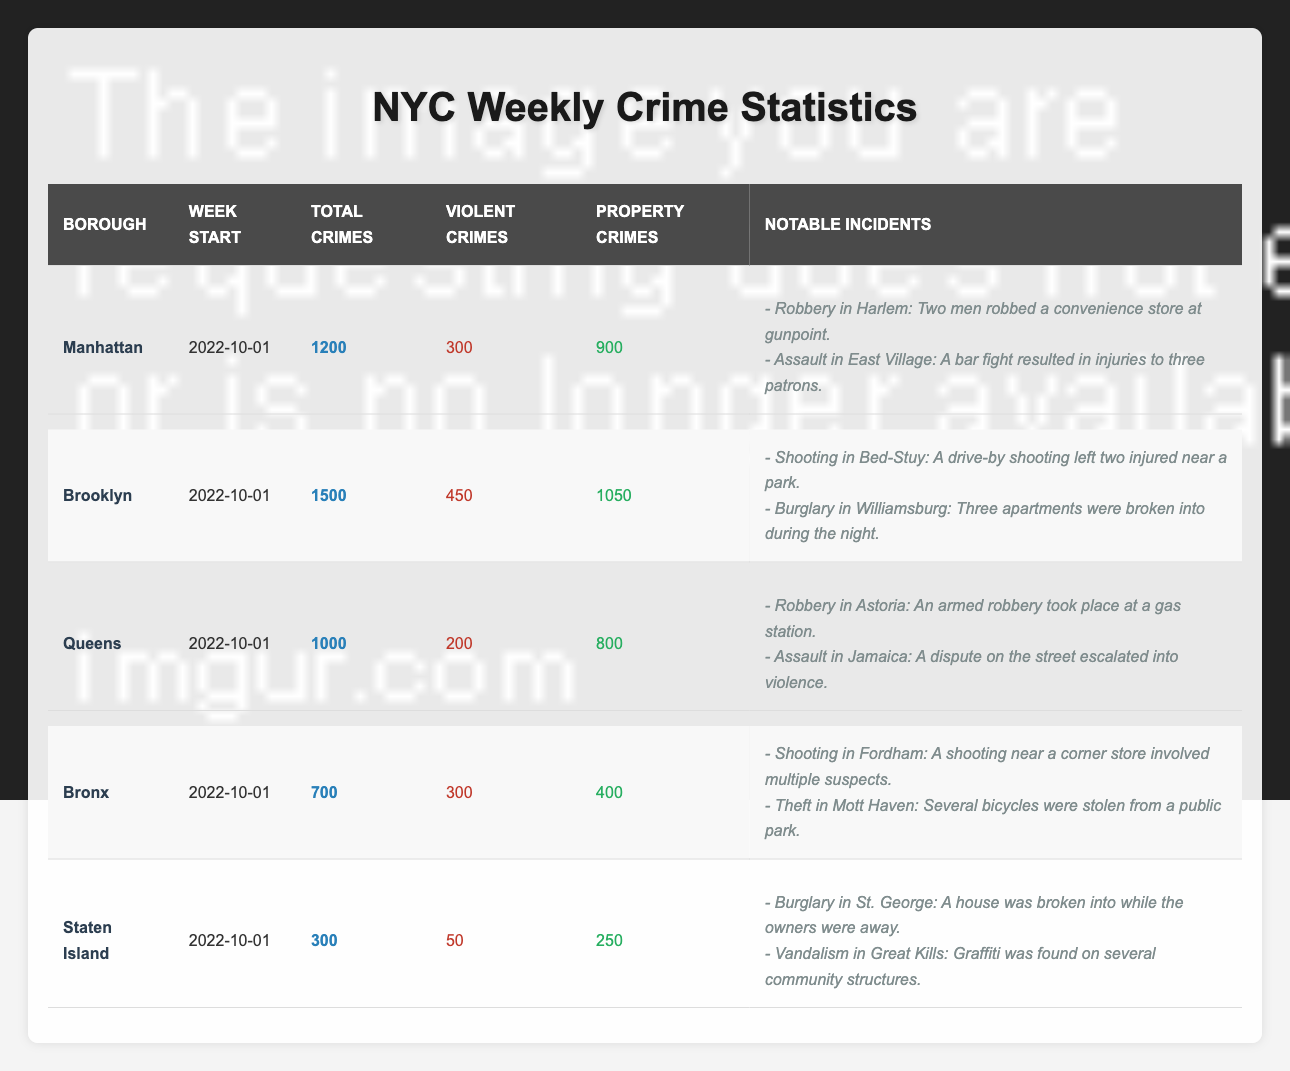What is the total number of crimes reported in Brooklyn? The table shows that Brooklyn has a total of 1500 crimes reported during the week starting on October 1, 2022.
Answer: 1500 How many violent crimes occurred in Manhattan? According to the table, Manhattan reported 300 violent crimes for the week starting on October 1, 2022.
Answer: 300 Which borough had the highest number of property crimes? The values for property crimes are as follows: Bronx (400), Queens (800), Brooklyn (1050), Staten Island (250), and Manhattan (900). Brooklyn has the highest value at 1050 property crimes.
Answer: Brooklyn Did Staten Island have more total crimes than the Bronx? Staten Island reported 300 total crimes, while the Bronx had 700 total crimes. Since 700 is greater than 300, the statement is false.
Answer: No What is the combined total of violent crimes in Queens and Staten Island? Queens had 200 violent crimes and Staten Island had 50. Adding these gives 200 + 50 = 250.
Answer: 250 Which borough experienced the lowest total number of crimes, and what was the count? The total crimes for each borough are: Manhattan (1200), Brooklyn (1500), Queens (1000), Bronx (700), and Staten Island (300). Staten Island had the lowest count, which is 300.
Answer: Staten Island, 300 If we sum the total crimes from all boroughs, what is the total? The total crimes from each borough are 1200 (Manhattan) + 1500 (Brooklyn) + 1000 (Queens) + 700 (Bronx) + 300 (Staten Island) = 3700 total crimes.
Answer: 3700 What is the difference in total crimes between Brooklyn and the Bronx? Brooklyn reported 1500 total crimes and the Bronx reported 700. The difference is 1500 - 700 = 800.
Answer: 800 How many notable incidents were reported in Queens? The table shows two notable incidents for Queens: a robbery in Astoria and an assault in Jamaica, totaling to 2 notable incidents.
Answer: 2 